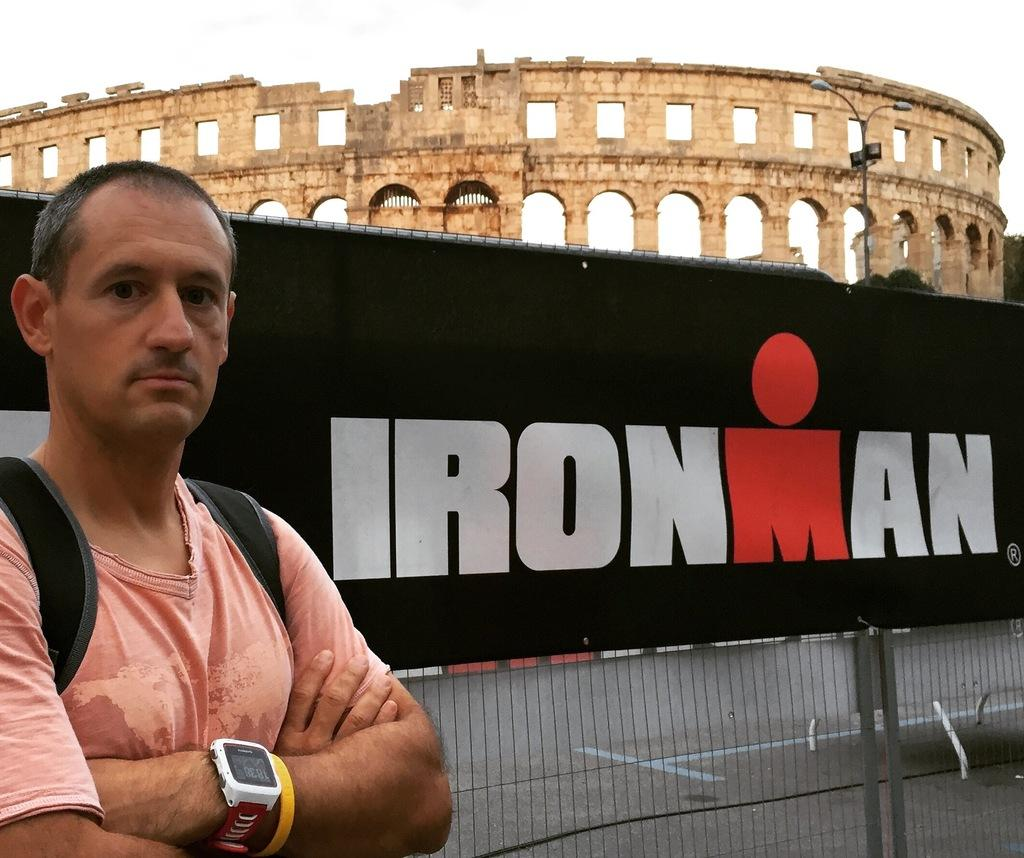<image>
Write a terse but informative summary of the picture. A man standing next to a sign that says Ironman 